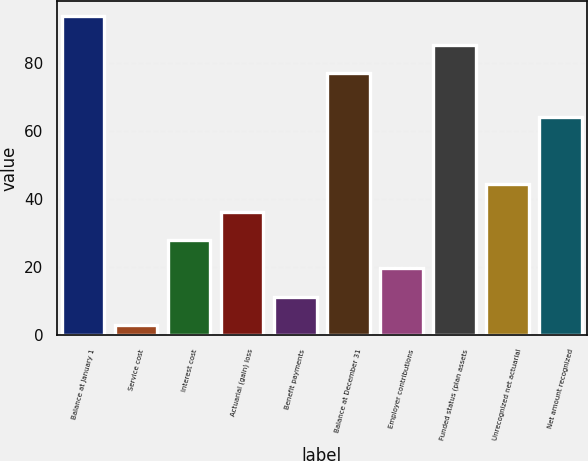Convert chart to OTSL. <chart><loc_0><loc_0><loc_500><loc_500><bar_chart><fcel>Balance at January 1<fcel>Service cost<fcel>Interest cost<fcel>Actuarial (gain) loss<fcel>Benefit payments<fcel>Balance at December 31<fcel>Employer contributions<fcel>Funded status (plan assets<fcel>Unrecognized net actuarial<fcel>Net amount recognized<nl><fcel>93.6<fcel>3<fcel>27.9<fcel>36.2<fcel>11.3<fcel>77<fcel>19.6<fcel>85.3<fcel>44.5<fcel>64<nl></chart> 